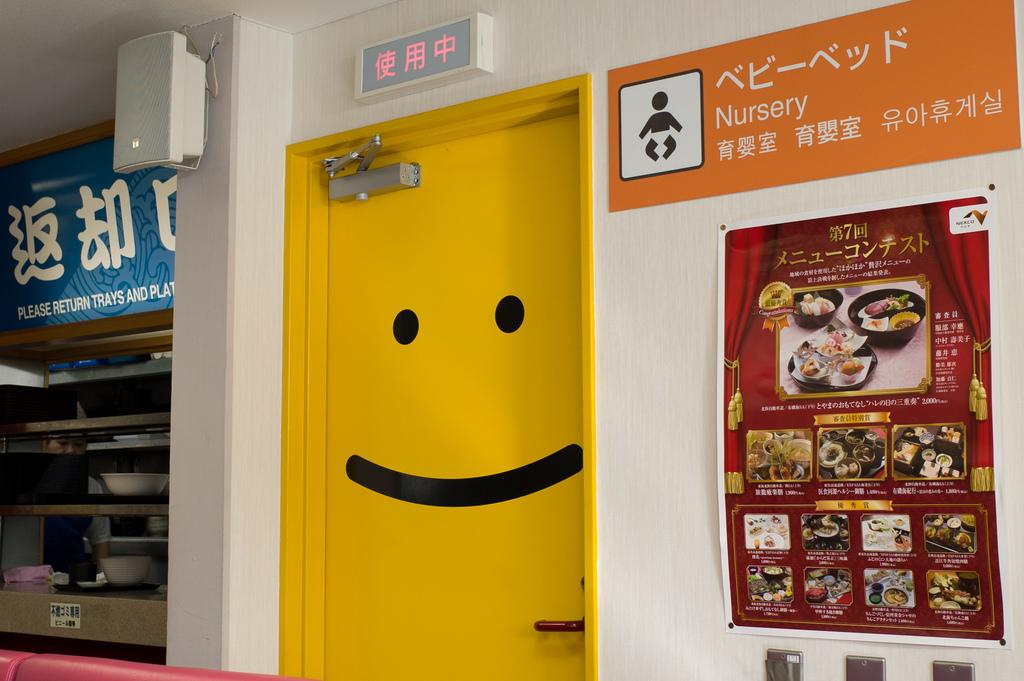<image>
Relay a brief, clear account of the picture shown. Yellow door with a smiley face on it and nursery written on orange sign next to it. 